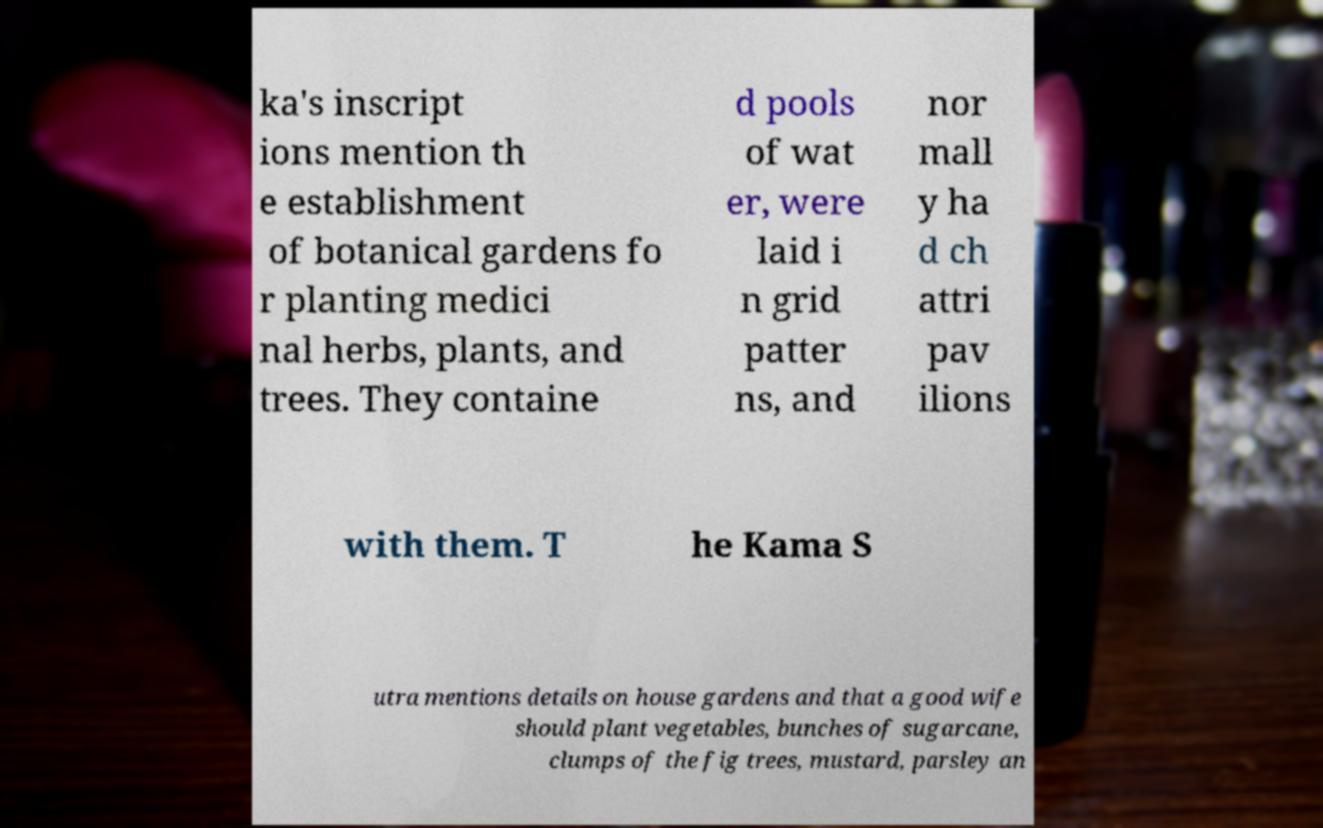Can you accurately transcribe the text from the provided image for me? ka's inscript ions mention th e establishment of botanical gardens fo r planting medici nal herbs, plants, and trees. They containe d pools of wat er, were laid i n grid patter ns, and nor mall y ha d ch attri pav ilions with them. T he Kama S utra mentions details on house gardens and that a good wife should plant vegetables, bunches of sugarcane, clumps of the fig trees, mustard, parsley an 